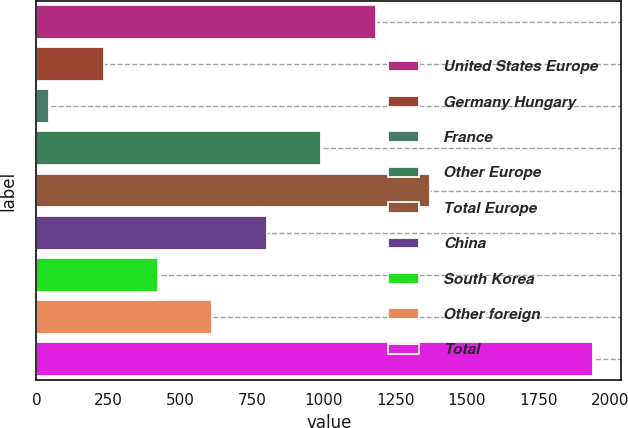<chart> <loc_0><loc_0><loc_500><loc_500><bar_chart><fcel>United States Europe<fcel>Germany Hungary<fcel>France<fcel>Other Europe<fcel>Total Europe<fcel>China<fcel>South Korea<fcel>Other foreign<fcel>Total<nl><fcel>1181.4<fcel>233.9<fcel>44.4<fcel>991.9<fcel>1370.9<fcel>802.4<fcel>423.4<fcel>612.9<fcel>1939.4<nl></chart> 